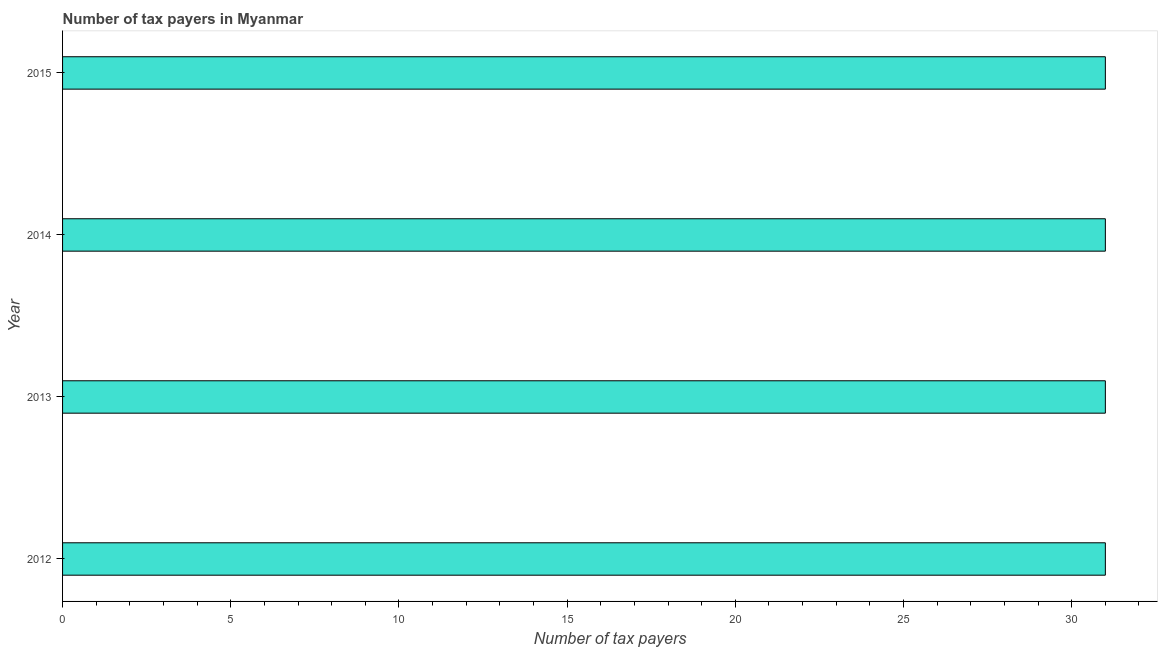Does the graph contain any zero values?
Make the answer very short. No. Does the graph contain grids?
Offer a very short reply. No. What is the title of the graph?
Your response must be concise. Number of tax payers in Myanmar. What is the label or title of the X-axis?
Provide a short and direct response. Number of tax payers. Across all years, what is the minimum number of tax payers?
Keep it short and to the point. 31. What is the sum of the number of tax payers?
Make the answer very short. 124. What is the difference between the number of tax payers in 2012 and 2013?
Provide a short and direct response. 0. In how many years, is the number of tax payers greater than 11 ?
Provide a succinct answer. 4. Is the difference between the number of tax payers in 2012 and 2015 greater than the difference between any two years?
Provide a short and direct response. Yes. What is the difference between the highest and the second highest number of tax payers?
Keep it short and to the point. 0. In how many years, is the number of tax payers greater than the average number of tax payers taken over all years?
Make the answer very short. 0. How many bars are there?
Offer a very short reply. 4. Are all the bars in the graph horizontal?
Your response must be concise. Yes. How many years are there in the graph?
Offer a very short reply. 4. Are the values on the major ticks of X-axis written in scientific E-notation?
Give a very brief answer. No. What is the Number of tax payers in 2013?
Your response must be concise. 31. What is the difference between the Number of tax payers in 2012 and 2013?
Provide a succinct answer. 0. What is the difference between the Number of tax payers in 2012 and 2014?
Keep it short and to the point. 0. What is the difference between the Number of tax payers in 2012 and 2015?
Give a very brief answer. 0. What is the difference between the Number of tax payers in 2014 and 2015?
Your response must be concise. 0. What is the ratio of the Number of tax payers in 2012 to that in 2013?
Keep it short and to the point. 1. What is the ratio of the Number of tax payers in 2012 to that in 2015?
Offer a terse response. 1. 